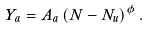<formula> <loc_0><loc_0><loc_500><loc_500>Y _ { a } = A _ { a } \left ( N - N _ { u } \right ) ^ { \phi } .</formula> 